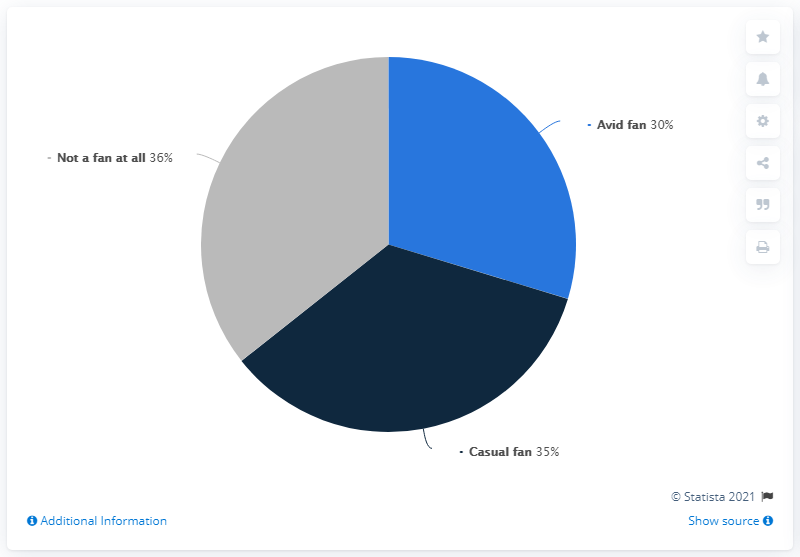Can the size of the segments provide other insights into the fan base? Certainly, the almost equal sizes of the segments indicate a balanced fan base with various levels of engagement. It's important for content creators to cater to each segment to maintain a diversified and inclusive approach that meets different fans' needs and preferences. If I wanted to increase the number of avid fans, what strategies could I employ? To increase the number of avid fans, consider creating more immersive experiences, such as offering behind-the-scenes content, fan meetups, or rewards programs. Fostering an active community through social media and fan clubs can also strengthen fan engagement and loyalty. 